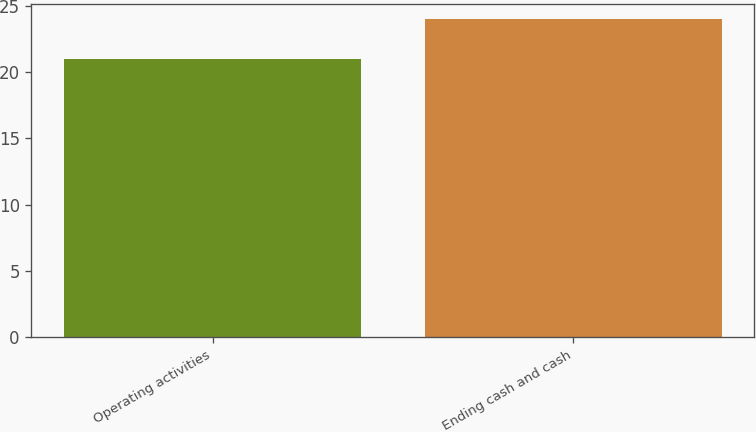<chart> <loc_0><loc_0><loc_500><loc_500><bar_chart><fcel>Operating activities<fcel>Ending cash and cash<nl><fcel>21<fcel>24<nl></chart> 